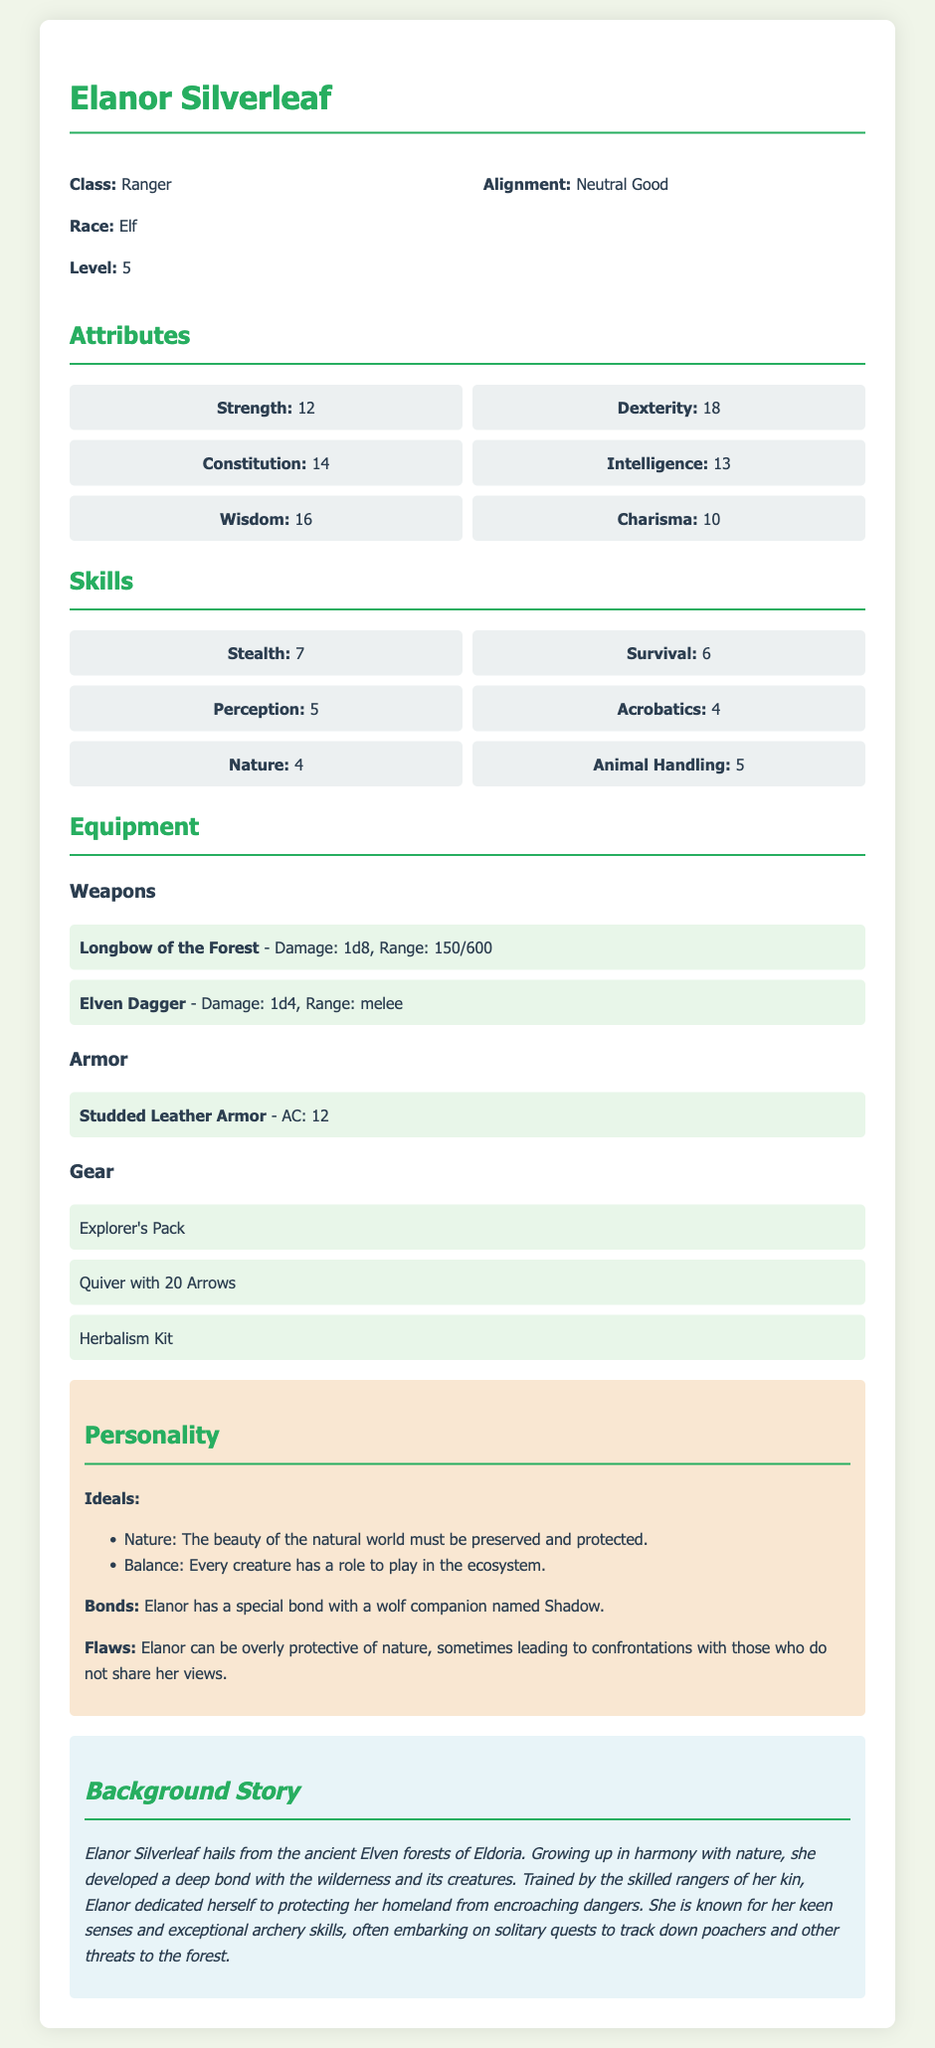What is the character's name? The character's name is presented prominently at the beginning of the document.
Answer: Elanor Silverleaf What is Elanor's class? The class is specified in the character information section.
Answer: Ranger What level is Elanor? The level is explicitly mentioned in the character information section.
Answer: 5 What is Elanor's Dexterity score? The Dexterity score is listed under the attributes section of the document.
Answer: 18 What is the damage of the Longbow of the Forest? The weapon information, including damage, is provided under the equipment section.
Answer: 1d8 How many skills does Elanor have listed? The skills section lists multiple skills, which can be counted.
Answer: 6 What is the special bond that Elanor has? The bond is outlined in the personality section of the document.
Answer: A wolf companion named Shadow What is Elanor's alignment? The alignment is stated in the character information section.
Answer: Neutral Good Where does Elanor hail from? The background story provides specific information about her origin.
Answer: Eldoria 